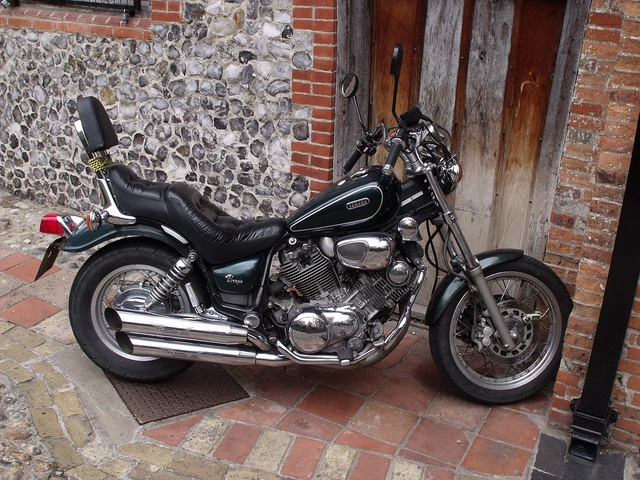Describe the objects in this image and their specific colors. I can see a motorcycle in gray, black, darkgray, and white tones in this image. 